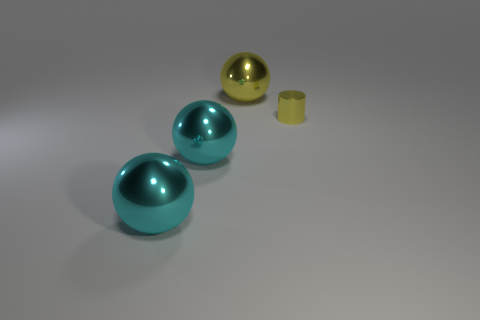Subtract all cyan shiny spheres. How many spheres are left? 1 Subtract all yellow balls. How many balls are left? 2 Subtract all yellow things. Subtract all big cyan objects. How many objects are left? 0 Add 1 yellow things. How many yellow things are left? 3 Add 4 cyan metal objects. How many cyan metal objects exist? 6 Add 2 yellow shiny balls. How many objects exist? 6 Subtract 0 purple spheres. How many objects are left? 4 Subtract all cylinders. How many objects are left? 3 Subtract 1 balls. How many balls are left? 2 Subtract all brown balls. Subtract all blue blocks. How many balls are left? 3 